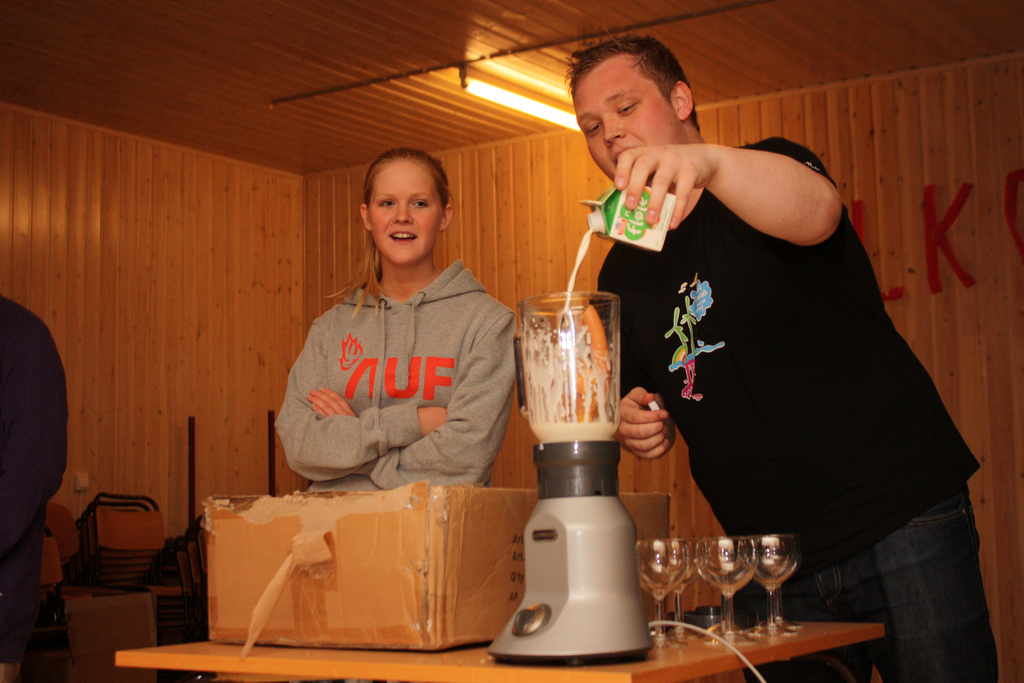Why might the girl be wearing a 'UF' sweatshirt? She is likely wearing a 'UF' sweatshirt as an indication of her affiliation or support for the University of Florida, commonly represented as 'UF' and known for its vibrant student life and academic community. 